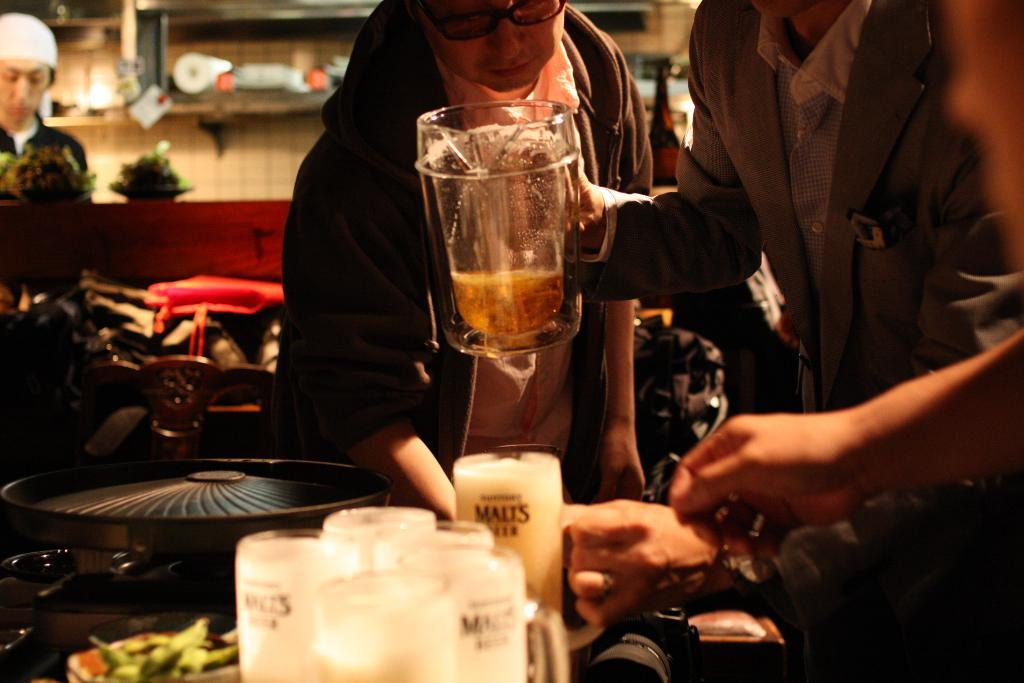What are the two persons in the image holding? The two persons in the image are holding wine glasses. Where are the wine glasses placed? The wine glasses are placed on a table. Can you describe the third person in the image? There is another person in the left corner of the image. What type of paste is being used by the passengers during their voyage in the image? There is no reference to passengers, a voyage, or paste in the image. The image features two persons holding wine glasses and another person in the left corner. 